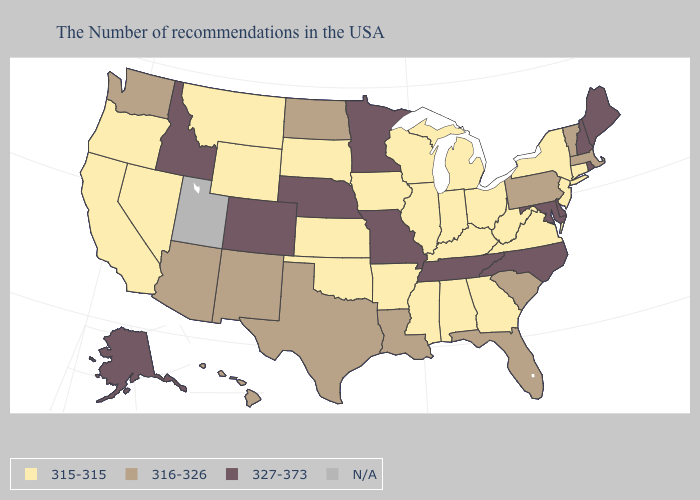Name the states that have a value in the range N/A?
Give a very brief answer. Utah. Name the states that have a value in the range 316-326?
Be succinct. Massachusetts, Vermont, Pennsylvania, South Carolina, Florida, Louisiana, Texas, North Dakota, New Mexico, Arizona, Washington, Hawaii. Does the first symbol in the legend represent the smallest category?
Quick response, please. Yes. What is the value of Connecticut?
Short answer required. 315-315. What is the highest value in the MidWest ?
Give a very brief answer. 327-373. What is the value of North Carolina?
Give a very brief answer. 327-373. What is the highest value in the USA?
Give a very brief answer. 327-373. Does the first symbol in the legend represent the smallest category?
Write a very short answer. Yes. What is the lowest value in the USA?
Be succinct. 315-315. Name the states that have a value in the range 327-373?
Keep it brief. Maine, Rhode Island, New Hampshire, Delaware, Maryland, North Carolina, Tennessee, Missouri, Minnesota, Nebraska, Colorado, Idaho, Alaska. Name the states that have a value in the range 327-373?
Write a very short answer. Maine, Rhode Island, New Hampshire, Delaware, Maryland, North Carolina, Tennessee, Missouri, Minnesota, Nebraska, Colorado, Idaho, Alaska. Does Arizona have the lowest value in the USA?
Short answer required. No. Among the states that border Washington , does Idaho have the lowest value?
Answer briefly. No. What is the value of New Mexico?
Concise answer only. 316-326. 